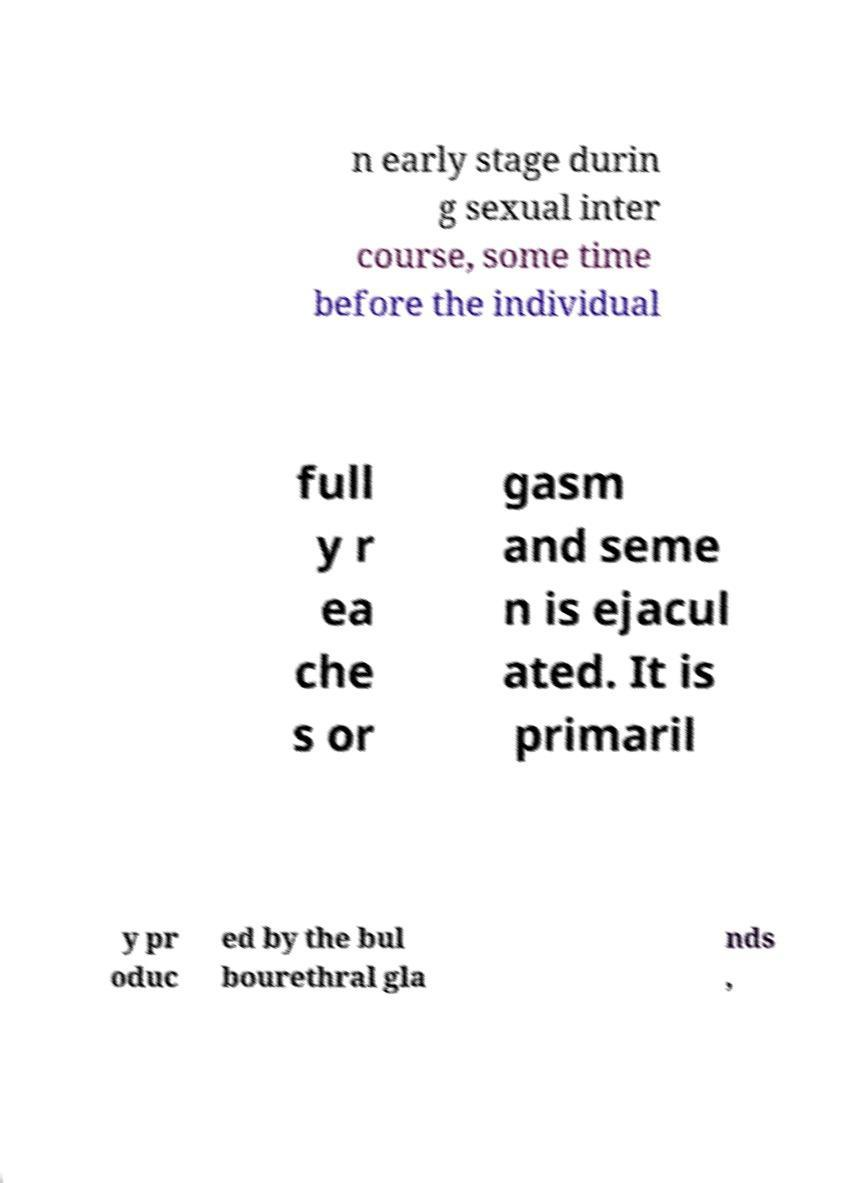There's text embedded in this image that I need extracted. Can you transcribe it verbatim? n early stage durin g sexual inter course, some time before the individual full y r ea che s or gasm and seme n is ejacul ated. It is primaril y pr oduc ed by the bul bourethral gla nds , 